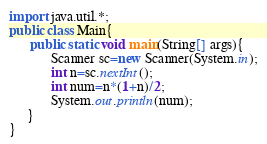<code> <loc_0><loc_0><loc_500><loc_500><_Java_>import java.util.*;
public class Main{
      public static void main(String[] args){
            Scanner sc=new Scanner(System.in);
            int n=sc.nextInt();
            int num=n*(1+n)/2;
            System.out.println(num);
     }
}</code> 